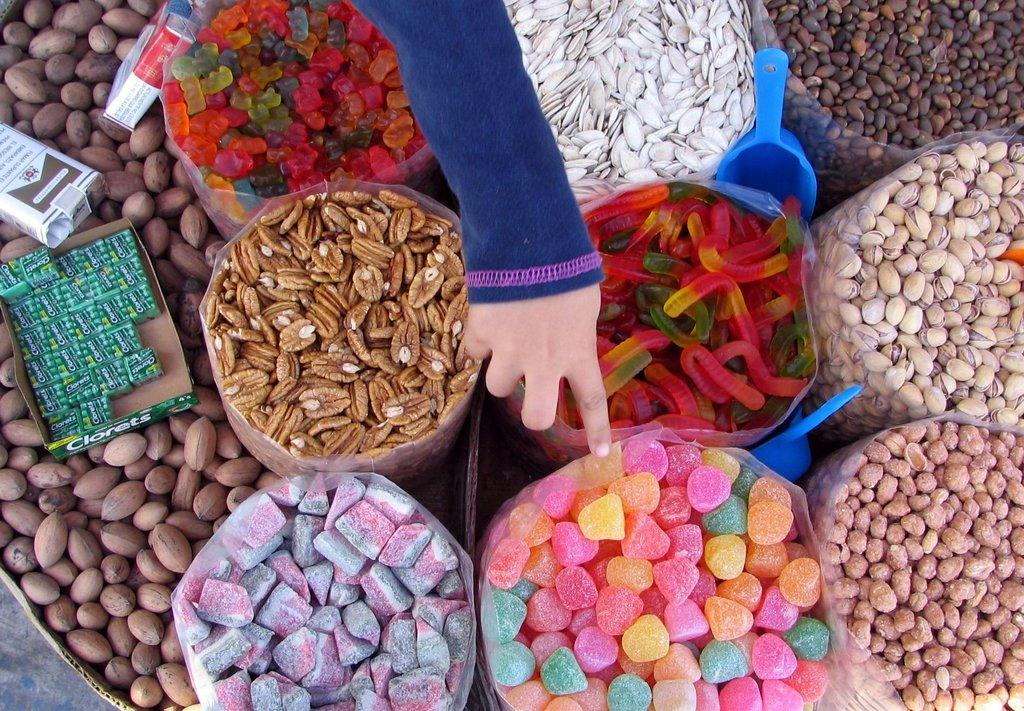What is contained within the plastic bag in the image? There are items in a plastic bag in the image. What color can be observed among the objects in the image? There are blue color objects in the image. What type of containers are present in the image? There are boxes in the image. Whose hand is visible in the image? A person's hand is visible in the image. Can you describe any other items that are not specified in the facts? There are other unspecified items in the image. How does the cow interact with the faucet in the image? There is no cow or faucet present in the image. 